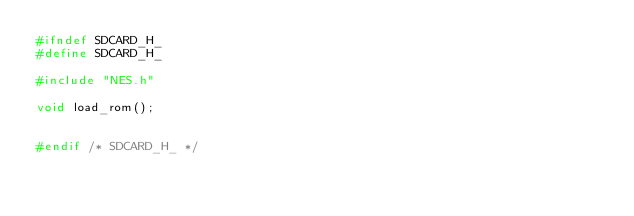<code> <loc_0><loc_0><loc_500><loc_500><_C_>#ifndef SDCARD_H_
#define SDCARD_H_

#include "NES.h"

void load_rom();


#endif /* SDCARD_H_ */
</code> 